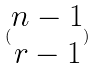Convert formula to latex. <formula><loc_0><loc_0><loc_500><loc_500>( \begin{matrix} n - 1 \\ r - 1 \end{matrix} )</formula> 